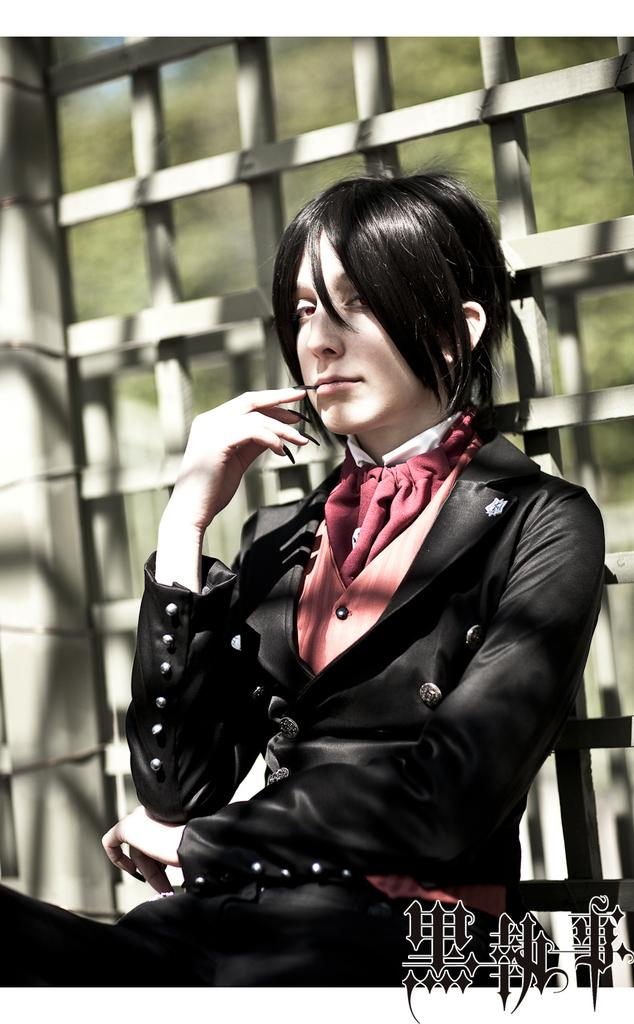Who is the main subject in the image? There is a lady in the image. What is located behind the lady? There is a fence behind the lady. What else can be seen in the image besides the lady and the fence? There is text visible in the image. How would you describe the background of the image? The background of the image is blurred. Can you tell me how many items the lady is shopping for in the image? There is no indication in the image that the lady is shopping or carrying any items. 